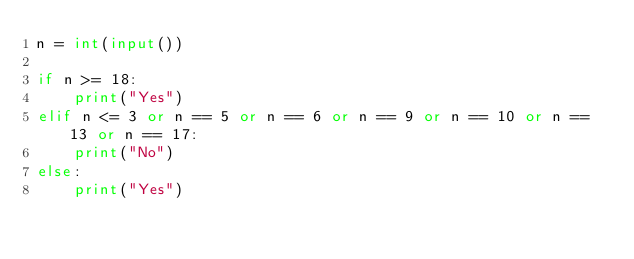<code> <loc_0><loc_0><loc_500><loc_500><_Python_>n = int(input())

if n >= 18:
    print("Yes")
elif n <= 3 or n == 5 or n == 6 or n == 9 or n == 10 or n == 13 or n == 17:
    print("No")
else:
    print("Yes")</code> 